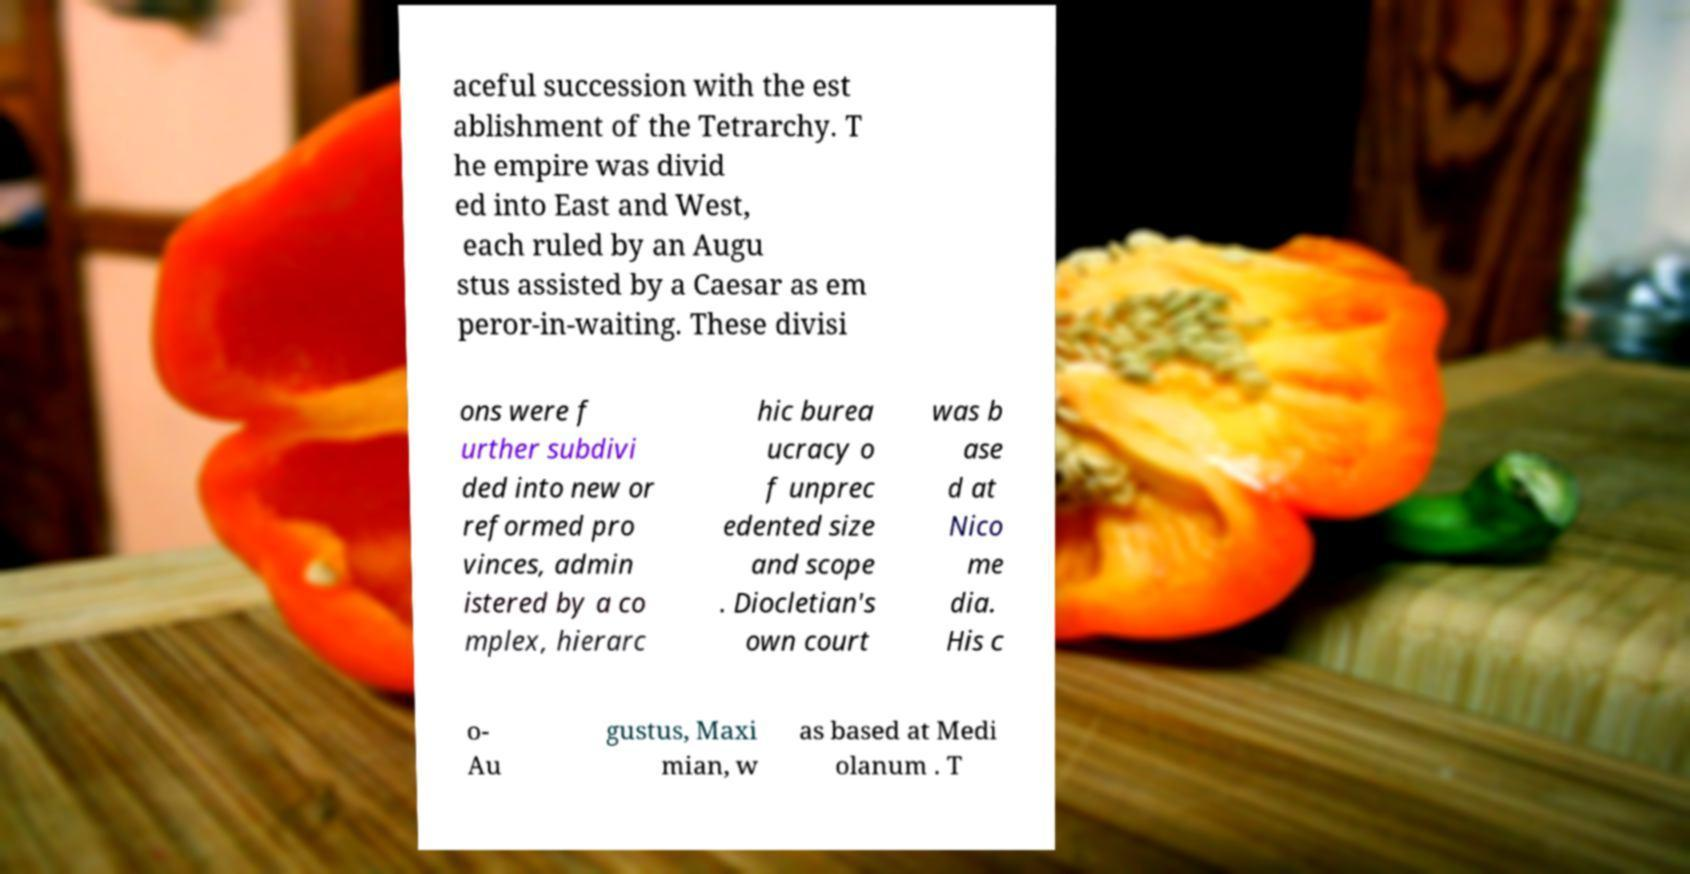Can you read and provide the text displayed in the image?This photo seems to have some interesting text. Can you extract and type it out for me? aceful succession with the est ablishment of the Tetrarchy. T he empire was divid ed into East and West, each ruled by an Augu stus assisted by a Caesar as em peror-in-waiting. These divisi ons were f urther subdivi ded into new or reformed pro vinces, admin istered by a co mplex, hierarc hic burea ucracy o f unprec edented size and scope . Diocletian's own court was b ase d at Nico me dia. His c o- Au gustus, Maxi mian, w as based at Medi olanum . T 